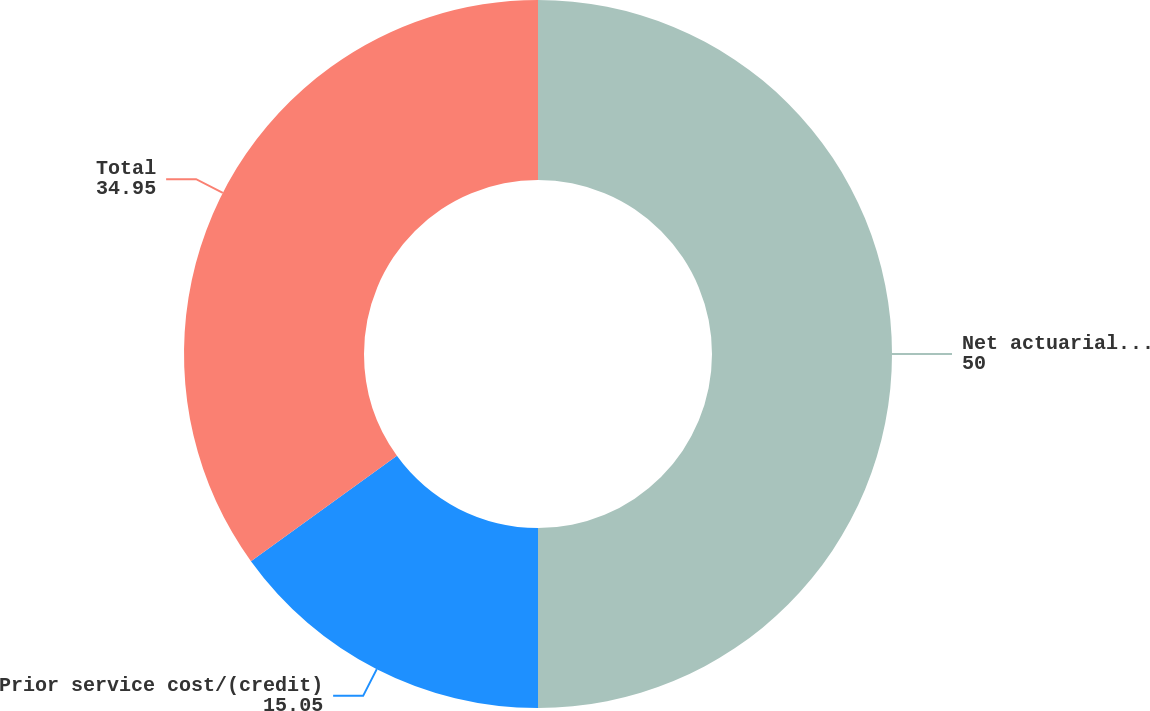Convert chart. <chart><loc_0><loc_0><loc_500><loc_500><pie_chart><fcel>Net actuarial loss/(gain)<fcel>Prior service cost/(credit)<fcel>Total<nl><fcel>50.0%<fcel>15.05%<fcel>34.95%<nl></chart> 